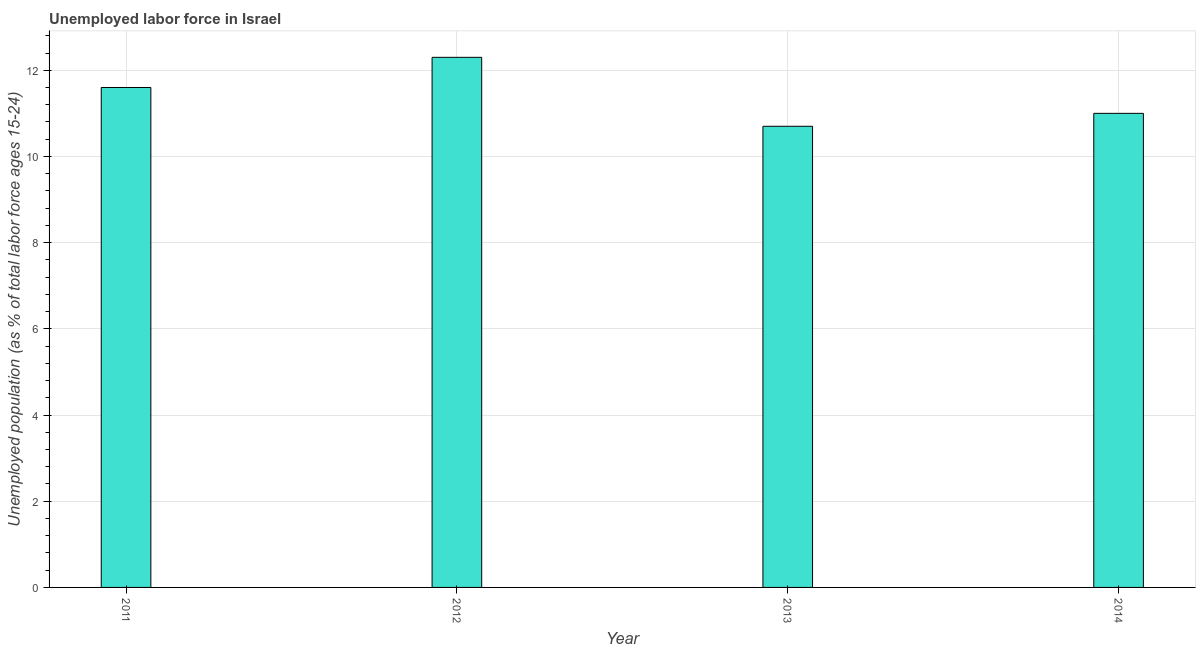Does the graph contain grids?
Your answer should be compact. Yes. What is the title of the graph?
Your answer should be very brief. Unemployed labor force in Israel. What is the label or title of the X-axis?
Your response must be concise. Year. What is the label or title of the Y-axis?
Give a very brief answer. Unemployed population (as % of total labor force ages 15-24). What is the total unemployed youth population in 2011?
Your response must be concise. 11.6. Across all years, what is the maximum total unemployed youth population?
Your answer should be very brief. 12.3. Across all years, what is the minimum total unemployed youth population?
Your response must be concise. 10.7. In which year was the total unemployed youth population maximum?
Offer a terse response. 2012. What is the sum of the total unemployed youth population?
Your response must be concise. 45.6. What is the average total unemployed youth population per year?
Provide a short and direct response. 11.4. What is the median total unemployed youth population?
Your response must be concise. 11.3. Do a majority of the years between 2011 and 2013 (inclusive) have total unemployed youth population greater than 11.6 %?
Your response must be concise. Yes. What is the ratio of the total unemployed youth population in 2012 to that in 2014?
Your response must be concise. 1.12. Is the difference between the total unemployed youth population in 2011 and 2012 greater than the difference between any two years?
Provide a short and direct response. No. Are all the bars in the graph horizontal?
Offer a very short reply. No. What is the Unemployed population (as % of total labor force ages 15-24) in 2011?
Offer a very short reply. 11.6. What is the Unemployed population (as % of total labor force ages 15-24) in 2012?
Provide a short and direct response. 12.3. What is the Unemployed population (as % of total labor force ages 15-24) of 2013?
Keep it short and to the point. 10.7. What is the difference between the Unemployed population (as % of total labor force ages 15-24) in 2011 and 2012?
Offer a very short reply. -0.7. What is the difference between the Unemployed population (as % of total labor force ages 15-24) in 2011 and 2014?
Your answer should be compact. 0.6. What is the difference between the Unemployed population (as % of total labor force ages 15-24) in 2012 and 2013?
Offer a very short reply. 1.6. What is the difference between the Unemployed population (as % of total labor force ages 15-24) in 2012 and 2014?
Provide a succinct answer. 1.3. What is the ratio of the Unemployed population (as % of total labor force ages 15-24) in 2011 to that in 2012?
Keep it short and to the point. 0.94. What is the ratio of the Unemployed population (as % of total labor force ages 15-24) in 2011 to that in 2013?
Offer a very short reply. 1.08. What is the ratio of the Unemployed population (as % of total labor force ages 15-24) in 2011 to that in 2014?
Your response must be concise. 1.05. What is the ratio of the Unemployed population (as % of total labor force ages 15-24) in 2012 to that in 2013?
Your answer should be very brief. 1.15. What is the ratio of the Unemployed population (as % of total labor force ages 15-24) in 2012 to that in 2014?
Your answer should be very brief. 1.12. What is the ratio of the Unemployed population (as % of total labor force ages 15-24) in 2013 to that in 2014?
Your answer should be compact. 0.97. 